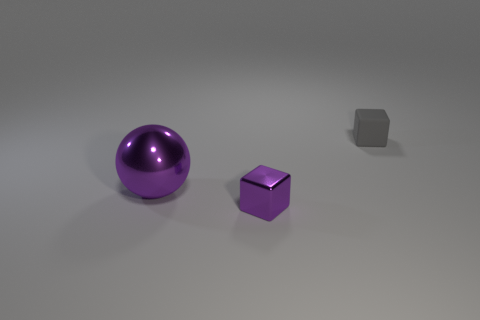Add 2 large cyan cubes. How many objects exist? 5 Subtract all spheres. How many objects are left? 2 Subtract all small red objects. Subtract all tiny cubes. How many objects are left? 1 Add 3 small metal objects. How many small metal objects are left? 4 Add 3 cyan metal balls. How many cyan metal balls exist? 3 Subtract 0 gray balls. How many objects are left? 3 